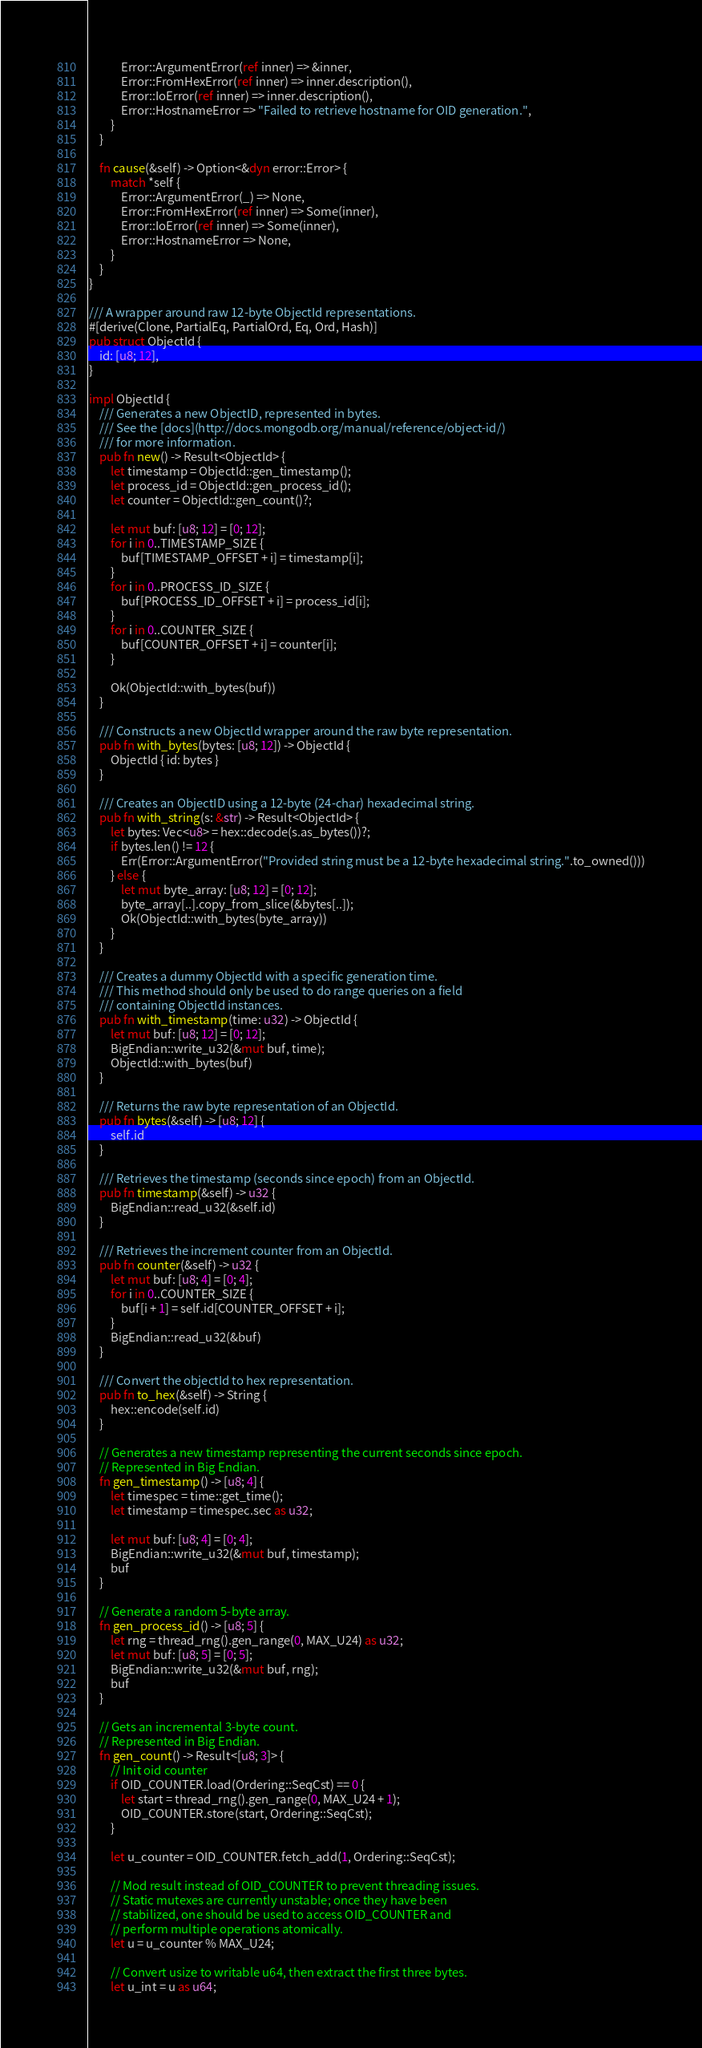Convert code to text. <code><loc_0><loc_0><loc_500><loc_500><_Rust_>            Error::ArgumentError(ref inner) => &inner,
            Error::FromHexError(ref inner) => inner.description(),
            Error::IoError(ref inner) => inner.description(),
            Error::HostnameError => "Failed to retrieve hostname for OID generation.",
        }
    }

    fn cause(&self) -> Option<&dyn error::Error> {
        match *self {
            Error::ArgumentError(_) => None,
            Error::FromHexError(ref inner) => Some(inner),
            Error::IoError(ref inner) => Some(inner),
            Error::HostnameError => None,
        }
    }
}

/// A wrapper around raw 12-byte ObjectId representations.
#[derive(Clone, PartialEq, PartialOrd, Eq, Ord, Hash)]
pub struct ObjectId {
    id: [u8; 12],
}

impl ObjectId {
    /// Generates a new ObjectID, represented in bytes.
    /// See the [docs](http://docs.mongodb.org/manual/reference/object-id/)
    /// for more information.
    pub fn new() -> Result<ObjectId> {
        let timestamp = ObjectId::gen_timestamp();
        let process_id = ObjectId::gen_process_id();
        let counter = ObjectId::gen_count()?;

        let mut buf: [u8; 12] = [0; 12];
        for i in 0..TIMESTAMP_SIZE {
            buf[TIMESTAMP_OFFSET + i] = timestamp[i];
        }
        for i in 0..PROCESS_ID_SIZE {
            buf[PROCESS_ID_OFFSET + i] = process_id[i];
        }
        for i in 0..COUNTER_SIZE {
            buf[COUNTER_OFFSET + i] = counter[i];
        }

        Ok(ObjectId::with_bytes(buf))
    }

    /// Constructs a new ObjectId wrapper around the raw byte representation.
    pub fn with_bytes(bytes: [u8; 12]) -> ObjectId {
        ObjectId { id: bytes }
    }

    /// Creates an ObjectID using a 12-byte (24-char) hexadecimal string.
    pub fn with_string(s: &str) -> Result<ObjectId> {
        let bytes: Vec<u8> = hex::decode(s.as_bytes())?;
        if bytes.len() != 12 {
            Err(Error::ArgumentError("Provided string must be a 12-byte hexadecimal string.".to_owned()))
        } else {
            let mut byte_array: [u8; 12] = [0; 12];
            byte_array[..].copy_from_slice(&bytes[..]);
            Ok(ObjectId::with_bytes(byte_array))
        }
    }

    /// Creates a dummy ObjectId with a specific generation time.
    /// This method should only be used to do range queries on a field
    /// containing ObjectId instances.
    pub fn with_timestamp(time: u32) -> ObjectId {
        let mut buf: [u8; 12] = [0; 12];
        BigEndian::write_u32(&mut buf, time);
        ObjectId::with_bytes(buf)
    }

    /// Returns the raw byte representation of an ObjectId.
    pub fn bytes(&self) -> [u8; 12] {
        self.id
    }

    /// Retrieves the timestamp (seconds since epoch) from an ObjectId.
    pub fn timestamp(&self) -> u32 {
        BigEndian::read_u32(&self.id)
    }

    /// Retrieves the increment counter from an ObjectId.
    pub fn counter(&self) -> u32 {
        let mut buf: [u8; 4] = [0; 4];
        for i in 0..COUNTER_SIZE {
            buf[i + 1] = self.id[COUNTER_OFFSET + i];
        }
        BigEndian::read_u32(&buf)
    }

    /// Convert the objectId to hex representation.
    pub fn to_hex(&self) -> String {
        hex::encode(self.id)
    }

    // Generates a new timestamp representing the current seconds since epoch.
    // Represented in Big Endian.
    fn gen_timestamp() -> [u8; 4] {
        let timespec = time::get_time();
        let timestamp = timespec.sec as u32;

        let mut buf: [u8; 4] = [0; 4];
        BigEndian::write_u32(&mut buf, timestamp);
        buf
    }

    // Generate a random 5-byte array.
    fn gen_process_id() -> [u8; 5] {
        let rng = thread_rng().gen_range(0, MAX_U24) as u32;
        let mut buf: [u8; 5] = [0; 5];
        BigEndian::write_u32(&mut buf, rng);
        buf
    }

    // Gets an incremental 3-byte count.
    // Represented in Big Endian.
    fn gen_count() -> Result<[u8; 3]> {
        // Init oid counter
        if OID_COUNTER.load(Ordering::SeqCst) == 0 {
            let start = thread_rng().gen_range(0, MAX_U24 + 1);
            OID_COUNTER.store(start, Ordering::SeqCst);
        }

        let u_counter = OID_COUNTER.fetch_add(1, Ordering::SeqCst);

        // Mod result instead of OID_COUNTER to prevent threading issues.
        // Static mutexes are currently unstable; once they have been
        // stabilized, one should be used to access OID_COUNTER and
        // perform multiple operations atomically.
        let u = u_counter % MAX_U24;

        // Convert usize to writable u64, then extract the first three bytes.
        let u_int = u as u64;
</code> 